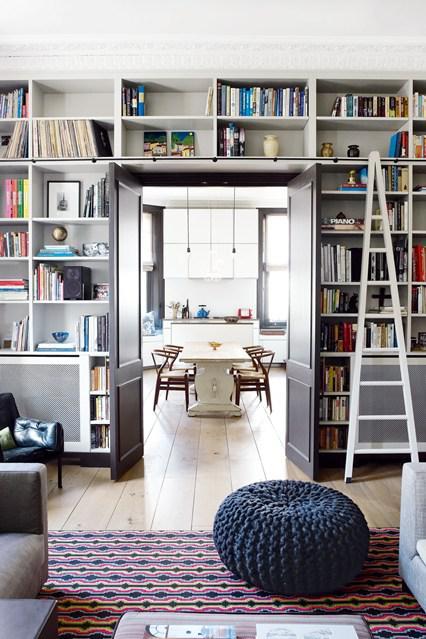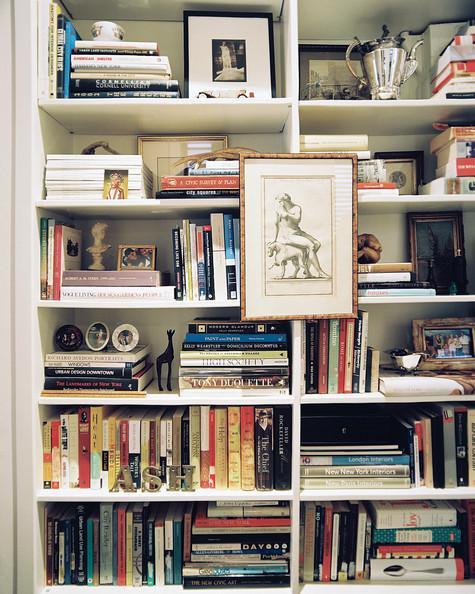The first image is the image on the left, the second image is the image on the right. Analyze the images presented: Is the assertion "One room has an opened doorway through the middle of a wall of white bookshelves." valid? Answer yes or no. Yes. The first image is the image on the left, the second image is the image on the right. Considering the images on both sides, is "In one image, a white shelving unit surrounds a central door that is standing open, with floor-to-ceiling shelves on both sides and over the door." valid? Answer yes or no. Yes. 